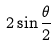Convert formula to latex. <formula><loc_0><loc_0><loc_500><loc_500>2 \sin \frac { \theta } { 2 }</formula> 